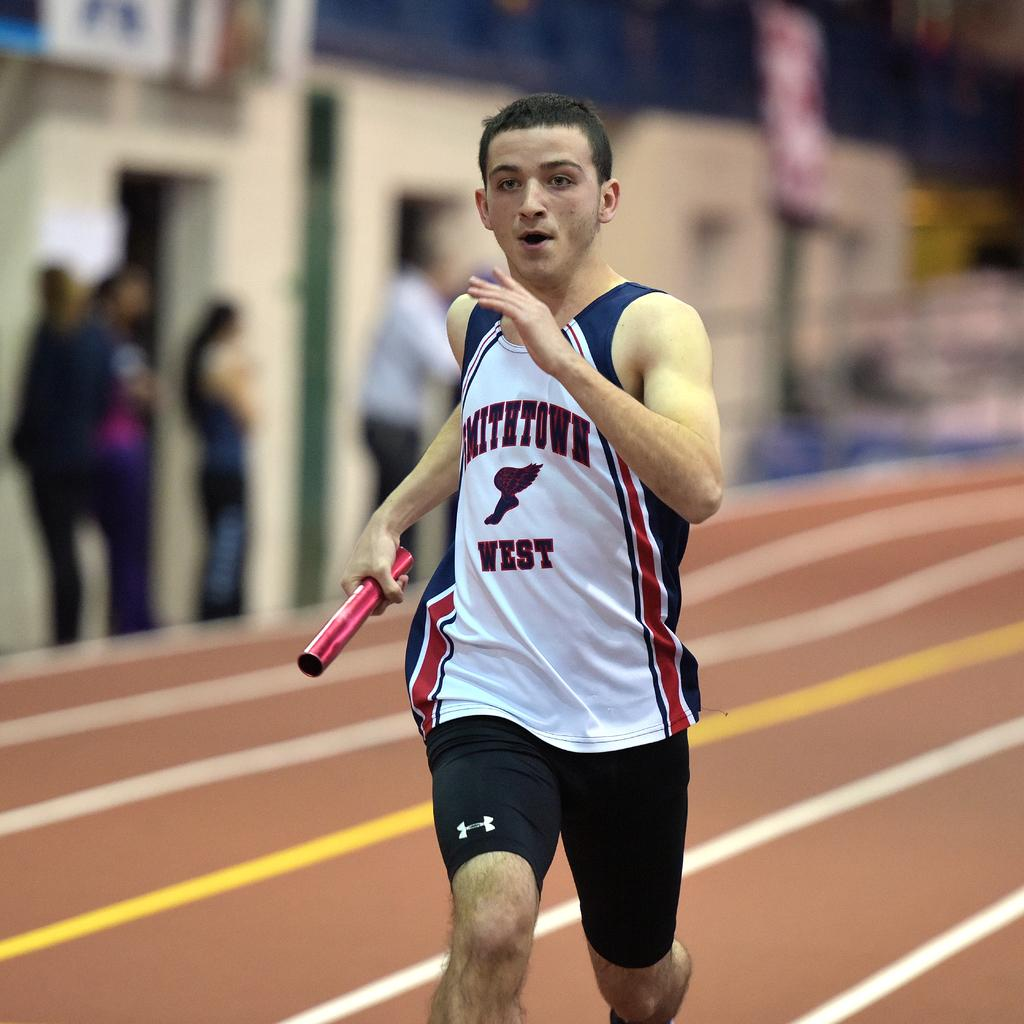Provide a one-sentence caption for the provided image. Smithtown west running team is racing on a track field with a baton. 